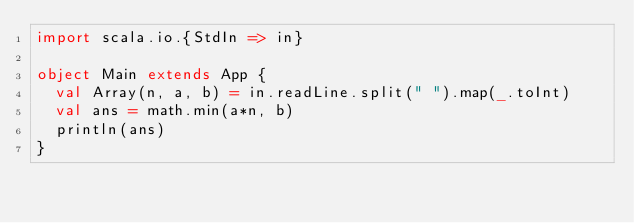Convert code to text. <code><loc_0><loc_0><loc_500><loc_500><_Scala_>import scala.io.{StdIn => in}

object Main extends App {
  val Array(n, a, b) = in.readLine.split(" ").map(_.toInt)
  val ans = math.min(a*n, b)
  println(ans)
}</code> 